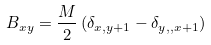Convert formula to latex. <formula><loc_0><loc_0><loc_500><loc_500>B _ { x y } = \frac { M } { 2 } \left ( \delta _ { x , y + 1 } - \delta _ { y , , x + 1 } \right )</formula> 